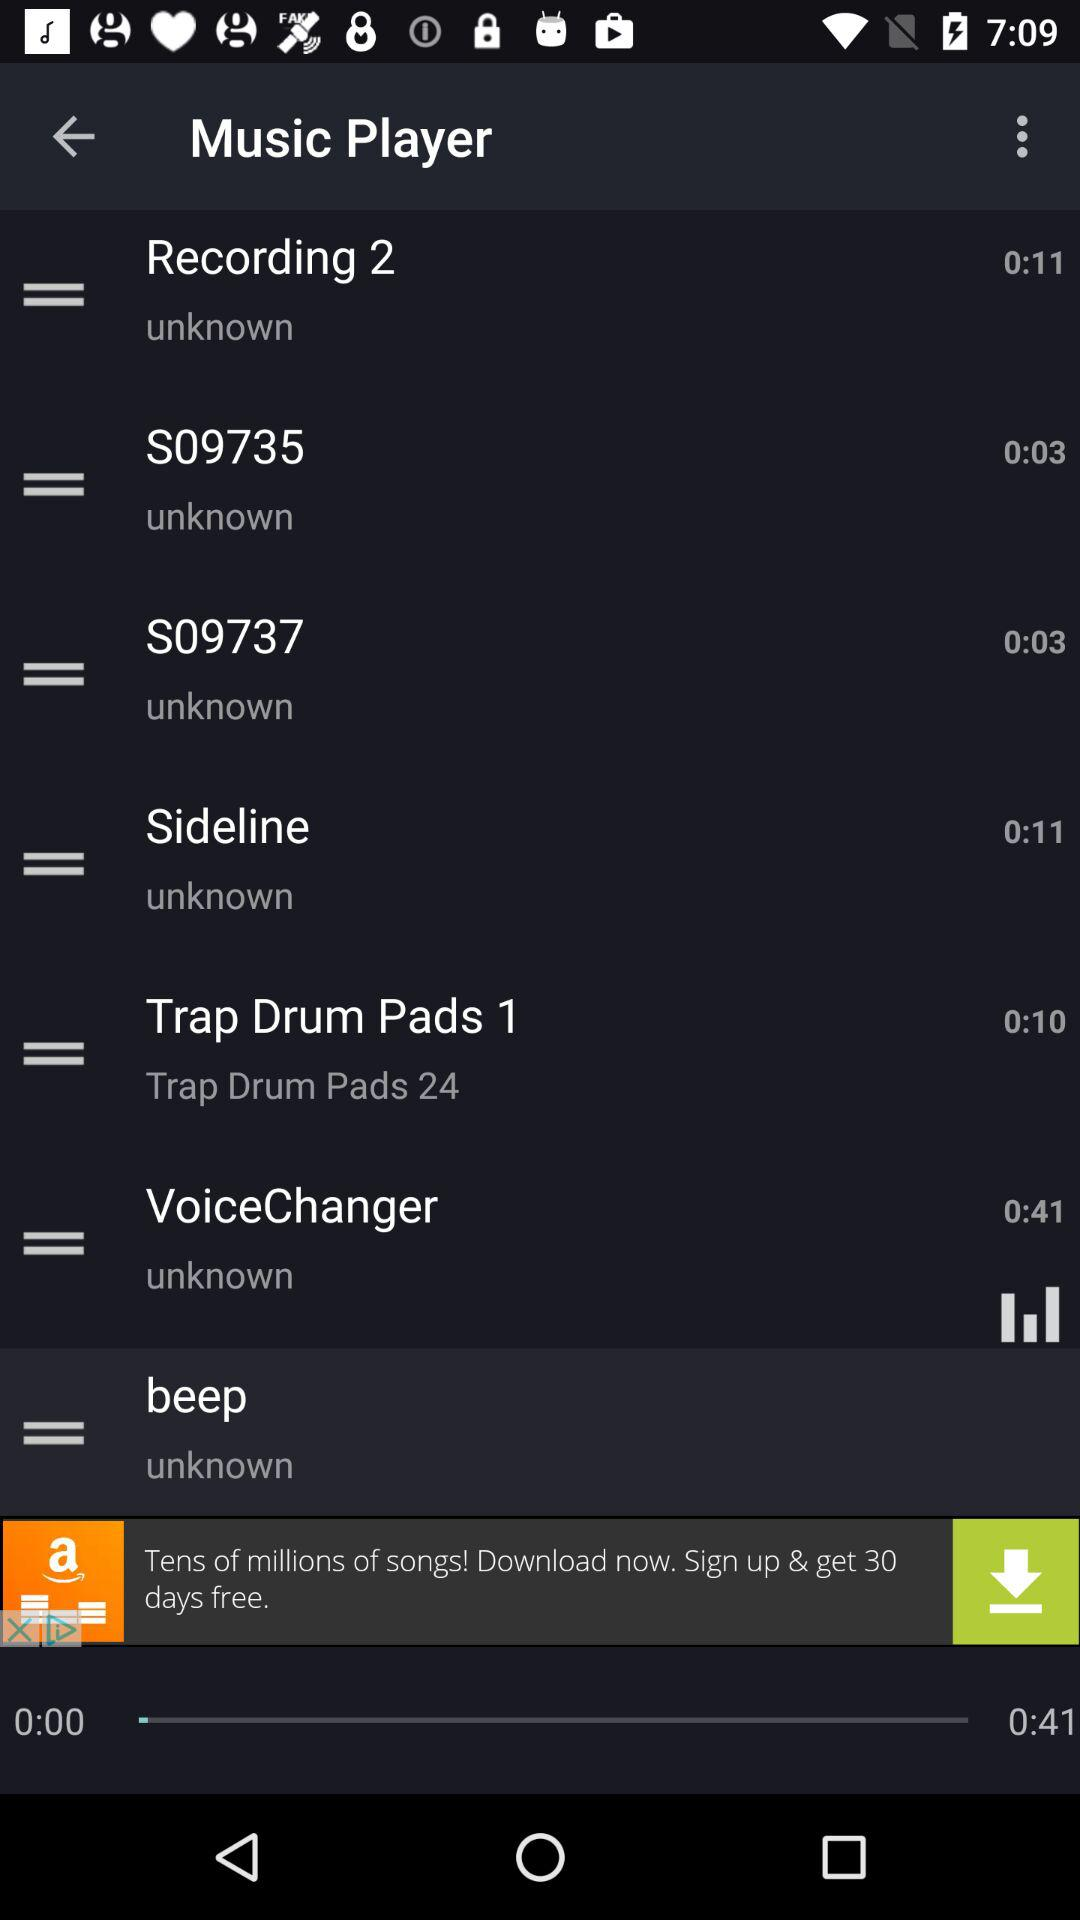What is the duration of "S09737"? The duration is 3 seconds. 